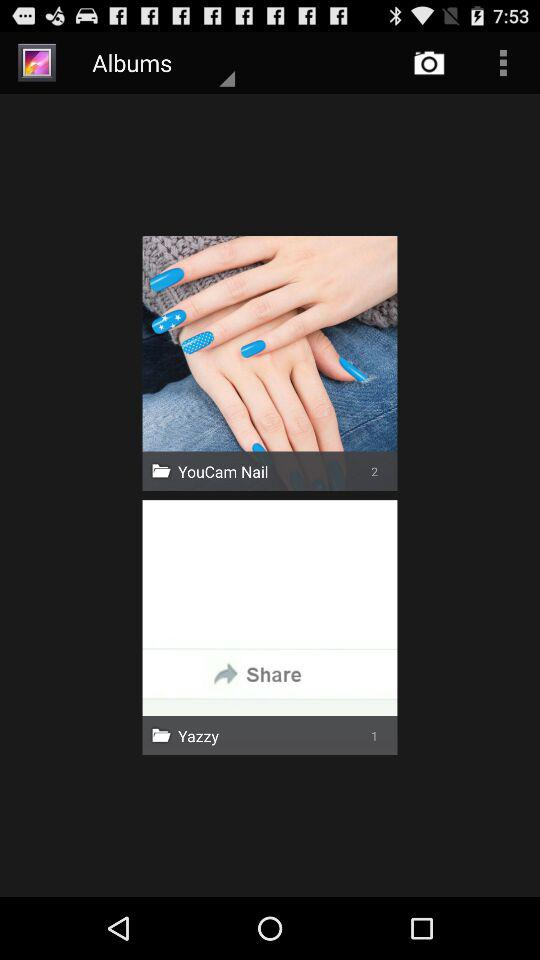How many more albums are there than Yeezys?
Answer the question using a single word or phrase. 1 